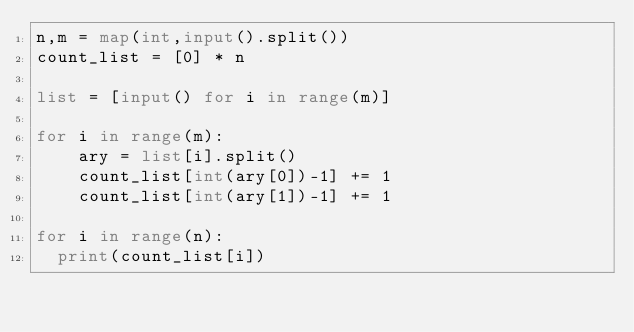Convert code to text. <code><loc_0><loc_0><loc_500><loc_500><_Python_>n,m = map(int,input().split())
count_list = [0] * n

list = [input() for i in range(m)]

for i in range(m):
    ary = list[i].split()
    count_list[int(ary[0])-1] += 1
    count_list[int(ary[1])-1] += 1

for i in range(n):
  print(count_list[i])</code> 